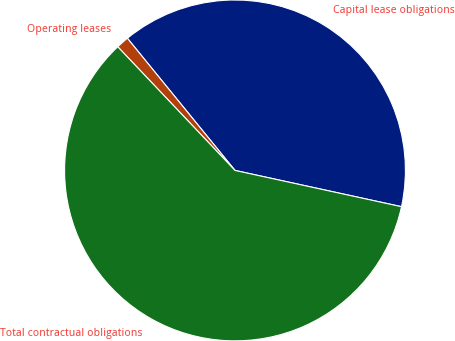<chart> <loc_0><loc_0><loc_500><loc_500><pie_chart><fcel>Capital lease obligations<fcel>Operating leases<fcel>Total contractual obligations<nl><fcel>39.29%<fcel>1.2%<fcel>59.51%<nl></chart> 